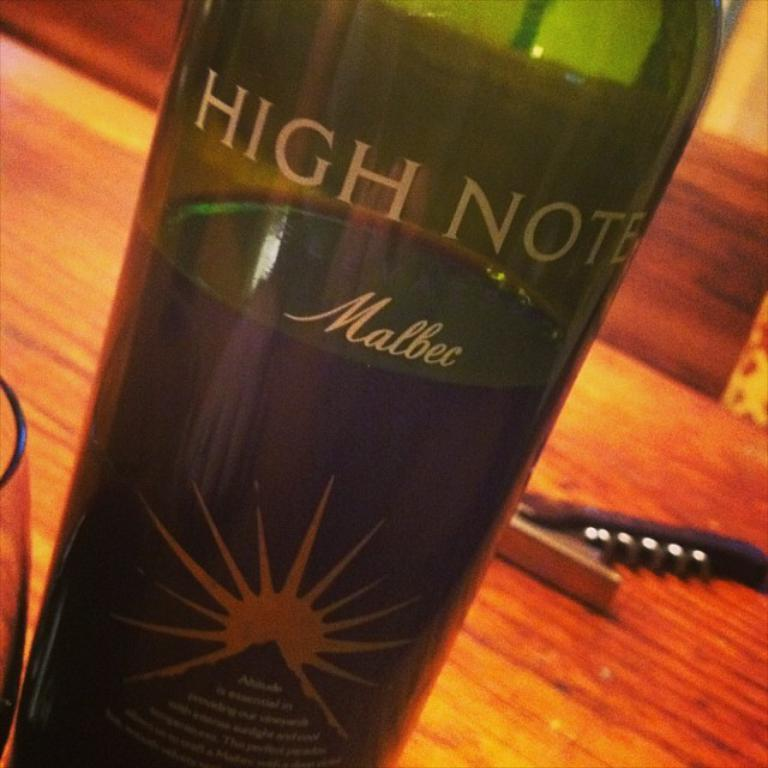<image>
Render a clear and concise summary of the photo. A tall green bottle of wine that reads High Note Malbec 